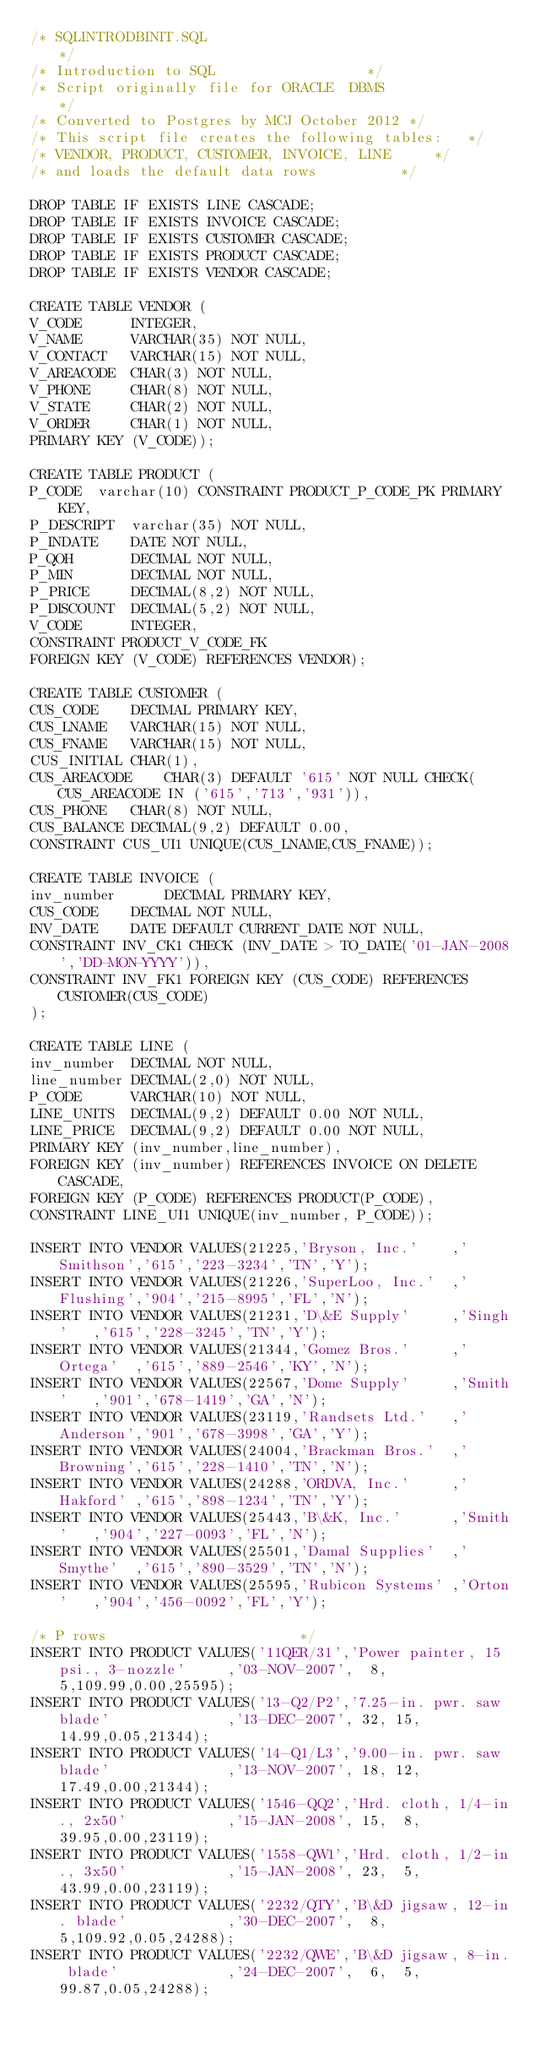Convert code to text. <code><loc_0><loc_0><loc_500><loc_500><_SQL_>/* SQLINTRODBINIT.SQL                                 	*/
/* Introduction to SQL 					*/
/* Script originally file for ORACLE  DBMS				*/
/* Converted to Postgres by MCJ October 2012 */
/* This script file creates the following tables:	*/
/* VENDOR, PRODUCT, CUSTOMER, INVOICE, LINE		*/
/* and loads the default data rows			*/

DROP TABLE IF EXISTS LINE CASCADE;
DROP TABLE IF EXISTS INVOICE CASCADE;
DROP TABLE IF EXISTS CUSTOMER CASCADE;
DROP TABLE IF EXISTS PRODUCT CASCADE;
DROP TABLE IF EXISTS VENDOR CASCADE;

CREATE TABLE VENDOR ( 
V_CODE 		INTEGER, 
V_NAME 		VARCHAR(35) NOT NULL, 
V_CONTACT 	VARCHAR(15) NOT NULL, 
V_AREACODE 	CHAR(3) NOT NULL, 
V_PHONE 	CHAR(8) NOT NULL, 
V_STATE 	CHAR(2) NOT NULL, 
V_ORDER 	CHAR(1) NOT NULL, 
PRIMARY KEY (V_CODE));

CREATE TABLE PRODUCT (
P_CODE 	varchar(10) CONSTRAINT PRODUCT_P_CODE_PK PRIMARY KEY,
P_DESCRIPT 	varchar(35) NOT NULL,
P_INDATE 	DATE NOT NULL,
P_QOH 	  	DECIMAL NOT NULL,
P_MIN 		DECIMAL NOT NULL,
P_PRICE 	DECIMAL(8,2) NOT NULL,
P_DISCOUNT 	DECIMAL(5,2) NOT NULL,
V_CODE 		INTEGER,
CONSTRAINT PRODUCT_V_CODE_FK
FOREIGN KEY (V_CODE) REFERENCES VENDOR);

CREATE TABLE CUSTOMER (
CUS_CODE	DECIMAL PRIMARY KEY,
CUS_LNAME	VARCHAR(15) NOT NULL,
CUS_FNAME	VARCHAR(15) NOT NULL,
CUS_INITIAL	CHAR(1),
CUS_AREACODE 	CHAR(3) DEFAULT '615' NOT NULL CHECK(CUS_AREACODE IN ('615','713','931')),
CUS_PHONE	CHAR(8) NOT NULL,
CUS_BALANCE	DECIMAL(9,2) DEFAULT 0.00,
CONSTRAINT CUS_UI1 UNIQUE(CUS_LNAME,CUS_FNAME));

CREATE TABLE INVOICE (
inv_number     	DECIMAL PRIMARY KEY,
CUS_CODE	DECIMAL NOT NULL, 
INV_DATE  	DATE DEFAULT CURRENT_DATE NOT NULL,
CONSTRAINT INV_CK1 CHECK (INV_DATE > TO_DATE('01-JAN-2008','DD-MON-YYYY')),
CONSTRAINT INV_FK1 FOREIGN KEY (CUS_CODE) REFERENCES CUSTOMER(CUS_CODE)
);

CREATE TABLE LINE (
inv_number 	DECIMAL NOT NULL,
line_number	DECIMAL(2,0) NOT NULL,
P_CODE		VARCHAR(10) NOT NULL,
LINE_UNITS	DECIMAL(9,2) DEFAULT 0.00 NOT NULL,
LINE_PRICE	DECIMAL(9,2) DEFAULT 0.00 NOT NULL,
PRIMARY KEY (inv_number,line_number),
FOREIGN KEY (inv_number) REFERENCES INVOICE ON DELETE CASCADE,
FOREIGN KEY (P_CODE) REFERENCES PRODUCT(P_CODE),
CONSTRAINT LINE_UI1 UNIQUE(inv_number, P_CODE));

INSERT INTO VENDOR VALUES(21225,'Bryson, Inc.'    ,'Smithson','615','223-3234','TN','Y');
INSERT INTO VENDOR VALUES(21226,'SuperLoo, Inc.'  ,'Flushing','904','215-8995','FL','N');
INSERT INTO VENDOR VALUES(21231,'D\&E Supply'     ,'Singh'   ,'615','228-3245','TN','Y');
INSERT INTO VENDOR VALUES(21344,'Gomez Bros.'     ,'Ortega'  ,'615','889-2546','KY','N');
INSERT INTO VENDOR VALUES(22567,'Dome Supply'     ,'Smith'   ,'901','678-1419','GA','N');
INSERT INTO VENDOR VALUES(23119,'Randsets Ltd.'   ,'Anderson','901','678-3998','GA','Y');
INSERT INTO VENDOR VALUES(24004,'Brackman Bros.'  ,'Browning','615','228-1410','TN','N');
INSERT INTO VENDOR VALUES(24288,'ORDVA, Inc.'     ,'Hakford' ,'615','898-1234','TN','Y');
INSERT INTO VENDOR VALUES(25443,'B\&K, Inc.'      ,'Smith'   ,'904','227-0093','FL','N');
INSERT INTO VENDOR VALUES(25501,'Damal Supplies'  ,'Smythe'  ,'615','890-3529','TN','N');
INSERT INTO VENDOR VALUES(25595,'Rubicon Systems' ,'Orton'   ,'904','456-0092','FL','Y');

/* P rows						*/
INSERT INTO PRODUCT VALUES('11QER/31','Power painter, 15 psi., 3-nozzle'     ,'03-NOV-2007',  8,  5,109.99,0.00,25595);
INSERT INTO PRODUCT VALUES('13-Q2/P2','7.25-in. pwr. saw blade'              ,'13-DEC-2007', 32, 15, 14.99,0.05,21344);
INSERT INTO PRODUCT VALUES('14-Q1/L3','9.00-in. pwr. saw blade'              ,'13-NOV-2007', 18, 12, 17.49,0.00,21344);
INSERT INTO PRODUCT VALUES('1546-QQ2','Hrd. cloth, 1/4-in., 2x50'            ,'15-JAN-2008', 15,  8, 39.95,0.00,23119);
INSERT INTO PRODUCT VALUES('1558-QW1','Hrd. cloth, 1/2-in., 3x50'            ,'15-JAN-2008', 23,  5, 43.99,0.00,23119);
INSERT INTO PRODUCT VALUES('2232/QTY','B\&D jigsaw, 12-in. blade'            ,'30-DEC-2007',  8,  5,109.92,0.05,24288);
INSERT INTO PRODUCT VALUES('2232/QWE','B\&D jigsaw, 8-in. blade'             ,'24-DEC-2007',  6,  5, 99.87,0.05,24288);</code> 